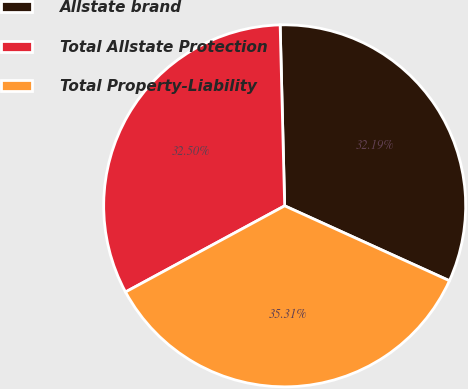Convert chart. <chart><loc_0><loc_0><loc_500><loc_500><pie_chart><fcel>Allstate brand<fcel>Total Allstate Protection<fcel>Total Property-Liability<nl><fcel>32.19%<fcel>32.5%<fcel>35.31%<nl></chart> 